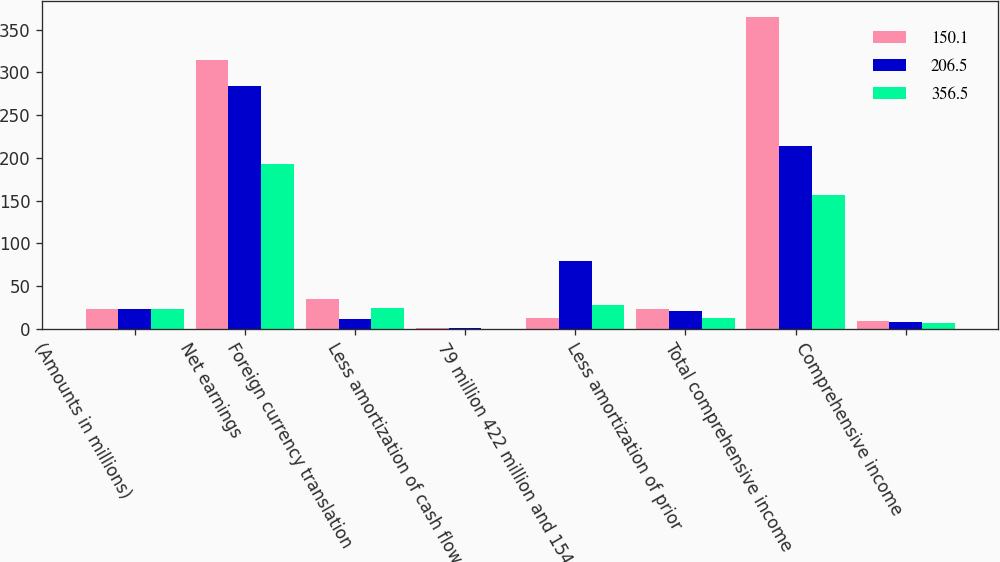Convert chart. <chart><loc_0><loc_0><loc_500><loc_500><stacked_bar_chart><ecel><fcel>(Amounts in millions)<fcel>Net earnings<fcel>Foreign currency translation<fcel>Less amortization of cash flow<fcel>79 million 422 million and 154<fcel>Less amortization of prior<fcel>Total comprehensive income<fcel>Comprehensive income<nl><fcel>150.1<fcel>22.7<fcel>314.6<fcel>35<fcel>0.4<fcel>12<fcel>22.7<fcel>365<fcel>8.5<nl><fcel>206.5<fcel>22.7<fcel>283.8<fcel>11.5<fcel>0.4<fcel>78.8<fcel>20.9<fcel>214<fcel>7.5<nl><fcel>356.5<fcel>22.7<fcel>193<fcel>24.7<fcel>0.1<fcel>27.3<fcel>12.9<fcel>156.6<fcel>6.8<nl></chart> 